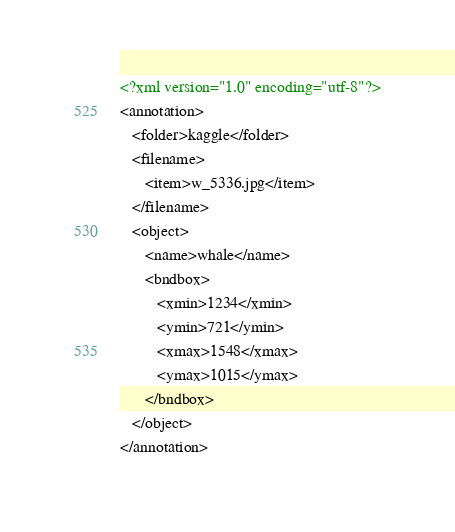Convert code to text. <code><loc_0><loc_0><loc_500><loc_500><_XML_><?xml version="1.0" encoding="utf-8"?>
<annotation>
   <folder>kaggle</folder>
   <filename>
      <item>w_5336.jpg</item>
   </filename>
   <object>
      <name>whale</name>
      <bndbox>
         <xmin>1234</xmin>
         <ymin>721</ymin>
         <xmax>1548</xmax>
         <ymax>1015</ymax>
      </bndbox>
   </object>
</annotation></code> 